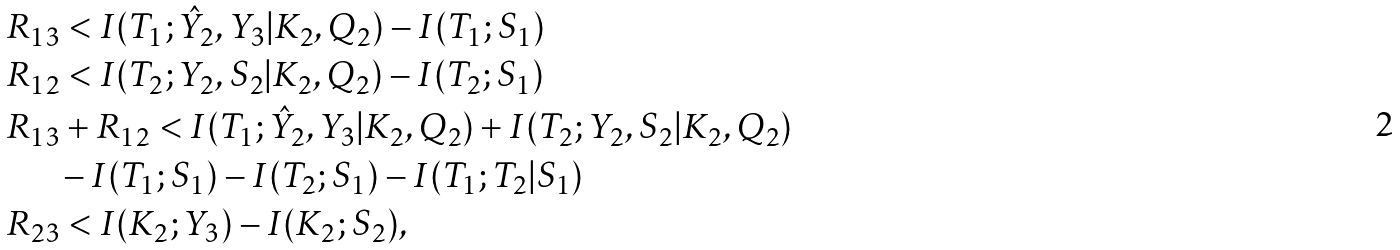Convert formula to latex. <formula><loc_0><loc_0><loc_500><loc_500>& \, R _ { 1 3 } < I ( T _ { 1 } ; \hat { Y } _ { 2 } , Y _ { 3 } | K _ { 2 } , Q _ { 2 } ) - I ( T _ { 1 } ; S _ { 1 } ) \\ & \, R _ { 1 2 } < I ( T _ { 2 } ; Y _ { 2 } , S _ { 2 } | K _ { 2 } , Q _ { 2 } ) - I ( T _ { 2 } ; S _ { 1 } ) \\ & \, R _ { 1 3 } + R _ { 1 2 } < I ( T _ { 1 } ; \hat { Y } _ { 2 } , Y _ { 3 } | K _ { 2 } , Q _ { 2 } ) + I ( T _ { 2 } ; Y _ { 2 } , S _ { 2 } | K _ { 2 } , Q _ { 2 } ) \\ & \quad \ \ - I ( T _ { 1 } ; S _ { 1 } ) - I ( T _ { 2 } ; S _ { 1 } ) - I ( T _ { 1 } ; T _ { 2 } | S _ { 1 } ) \\ & \, R _ { 2 3 } < I ( K _ { 2 } ; Y _ { 3 } ) - I ( K _ { 2 } ; S _ { 2 } ) ,</formula> 